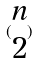<formula> <loc_0><loc_0><loc_500><loc_500>( \begin{matrix} n \\ 2 \end{matrix} )</formula> 